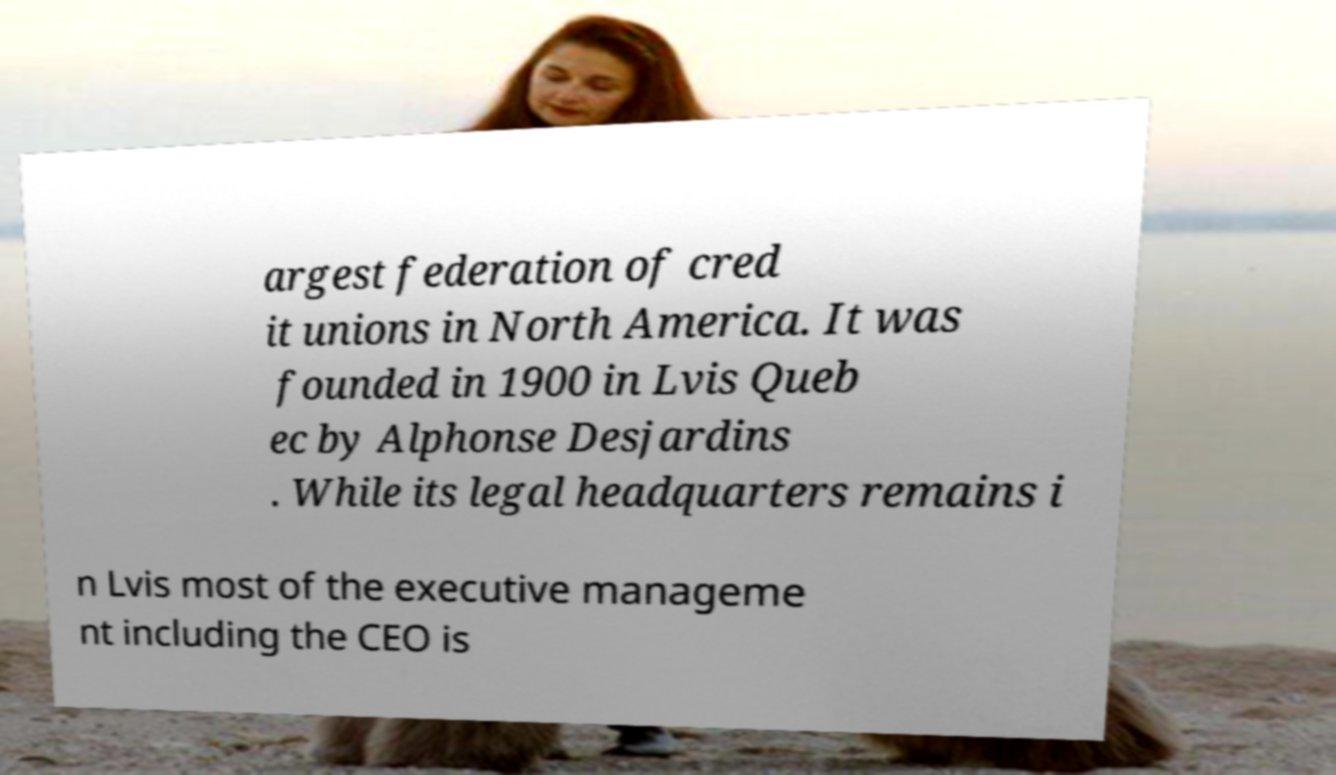What messages or text are displayed in this image? I need them in a readable, typed format. argest federation of cred it unions in North America. It was founded in 1900 in Lvis Queb ec by Alphonse Desjardins . While its legal headquarters remains i n Lvis most of the executive manageme nt including the CEO is 